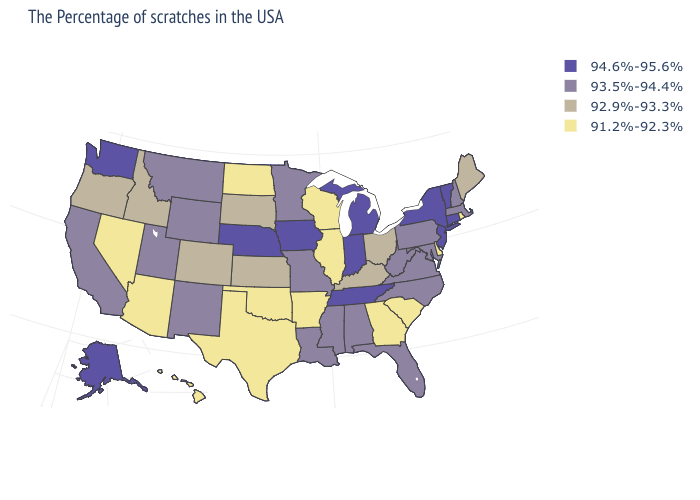What is the lowest value in the West?
Give a very brief answer. 91.2%-92.3%. Among the states that border Oregon , does Washington have the highest value?
Short answer required. Yes. Does South Carolina have the same value as Florida?
Concise answer only. No. Name the states that have a value in the range 94.6%-95.6%?
Keep it brief. Vermont, Connecticut, New York, New Jersey, Michigan, Indiana, Tennessee, Iowa, Nebraska, Washington, Alaska. Does Kansas have a higher value than Virginia?
Answer briefly. No. What is the value of Louisiana?
Be succinct. 93.5%-94.4%. Does Oklahoma have a lower value than Delaware?
Short answer required. No. What is the highest value in the Northeast ?
Concise answer only. 94.6%-95.6%. Name the states that have a value in the range 93.5%-94.4%?
Concise answer only. Massachusetts, New Hampshire, Maryland, Pennsylvania, Virginia, North Carolina, West Virginia, Florida, Alabama, Mississippi, Louisiana, Missouri, Minnesota, Wyoming, New Mexico, Utah, Montana, California. Does Illinois have the lowest value in the MidWest?
Keep it brief. Yes. What is the value of Maine?
Answer briefly. 92.9%-93.3%. Does the map have missing data?
Keep it brief. No. Name the states that have a value in the range 93.5%-94.4%?
Quick response, please. Massachusetts, New Hampshire, Maryland, Pennsylvania, Virginia, North Carolina, West Virginia, Florida, Alabama, Mississippi, Louisiana, Missouri, Minnesota, Wyoming, New Mexico, Utah, Montana, California. Among the states that border Mississippi , does Tennessee have the highest value?
Short answer required. Yes. 